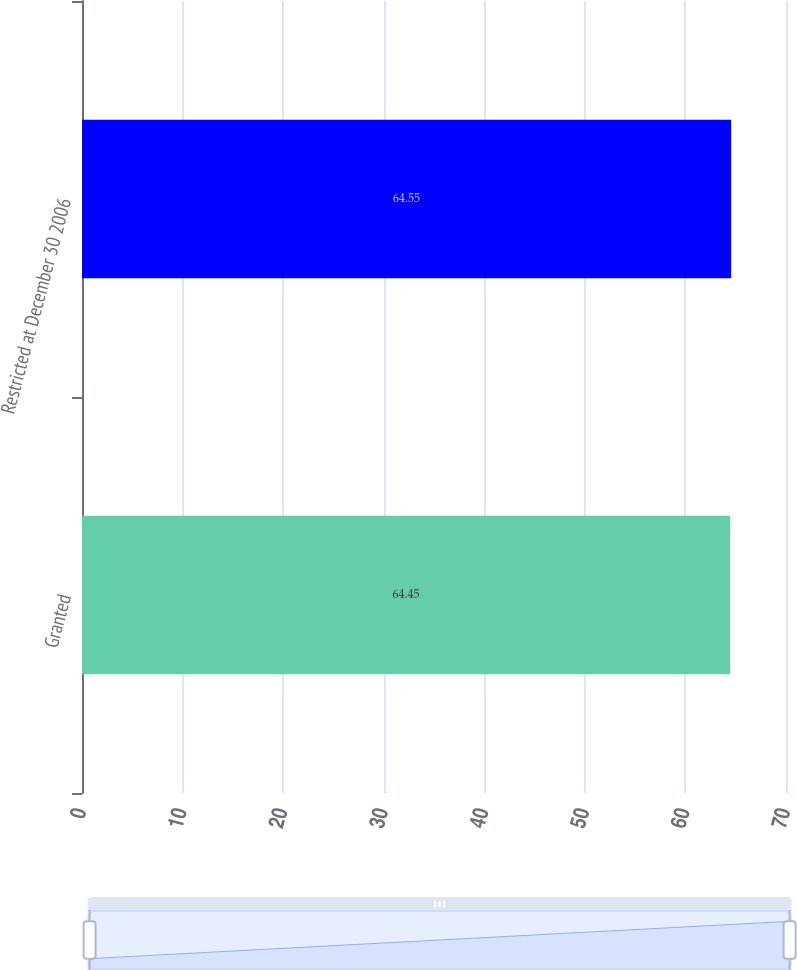Convert chart. <chart><loc_0><loc_0><loc_500><loc_500><bar_chart><fcel>Granted<fcel>Restricted at December 30 2006<nl><fcel>64.45<fcel>64.55<nl></chart> 